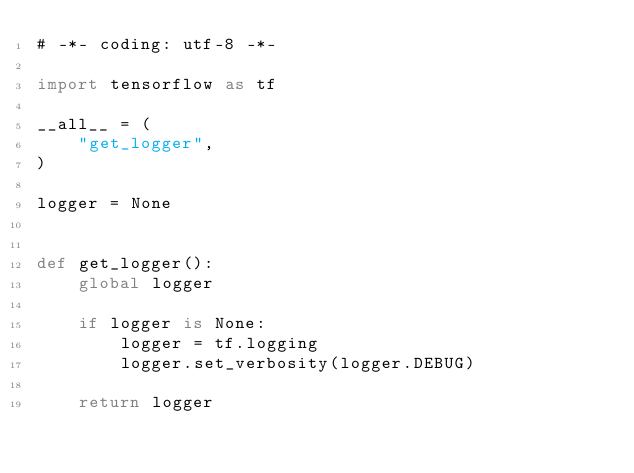Convert code to text. <code><loc_0><loc_0><loc_500><loc_500><_Python_># -*- coding: utf-8 -*-

import tensorflow as tf

__all__ = (
    "get_logger",
)

logger = None


def get_logger():
    global logger

    if logger is None:
        logger = tf.logging
        logger.set_verbosity(logger.DEBUG)

    return logger
</code> 